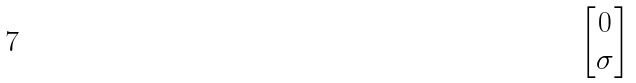<formula> <loc_0><loc_0><loc_500><loc_500>\begin{bmatrix} 0 \\ \sigma \end{bmatrix}</formula> 